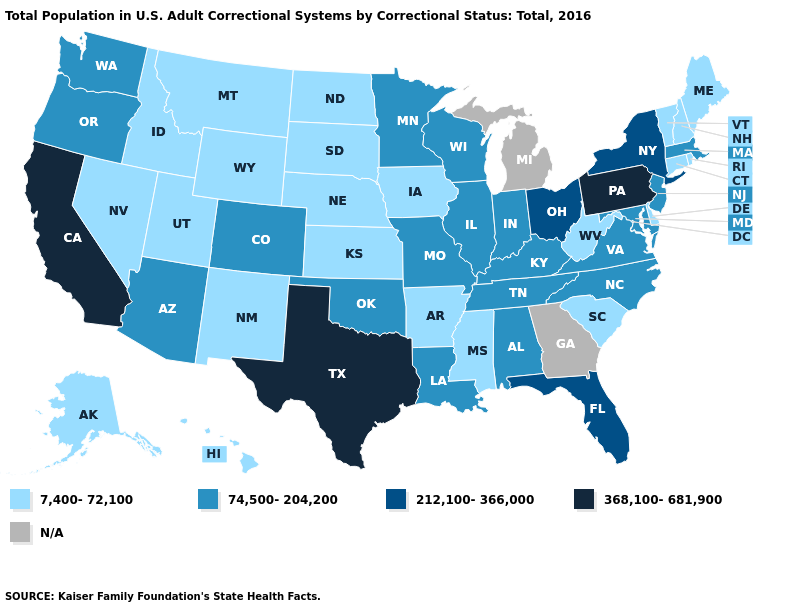What is the value of Nevada?
Write a very short answer. 7,400-72,100. Name the states that have a value in the range N/A?
Keep it brief. Georgia, Michigan. What is the value of Iowa?
Concise answer only. 7,400-72,100. Does the map have missing data?
Keep it brief. Yes. Among the states that border North Dakota , which have the lowest value?
Be succinct. Montana, South Dakota. Name the states that have a value in the range 7,400-72,100?
Answer briefly. Alaska, Arkansas, Connecticut, Delaware, Hawaii, Idaho, Iowa, Kansas, Maine, Mississippi, Montana, Nebraska, Nevada, New Hampshire, New Mexico, North Dakota, Rhode Island, South Carolina, South Dakota, Utah, Vermont, West Virginia, Wyoming. Does Louisiana have the lowest value in the South?
Be succinct. No. Name the states that have a value in the range 74,500-204,200?
Write a very short answer. Alabama, Arizona, Colorado, Illinois, Indiana, Kentucky, Louisiana, Maryland, Massachusetts, Minnesota, Missouri, New Jersey, North Carolina, Oklahoma, Oregon, Tennessee, Virginia, Washington, Wisconsin. Does Nebraska have the lowest value in the USA?
Concise answer only. Yes. What is the value of Alabama?
Concise answer only. 74,500-204,200. Name the states that have a value in the range 7,400-72,100?
Quick response, please. Alaska, Arkansas, Connecticut, Delaware, Hawaii, Idaho, Iowa, Kansas, Maine, Mississippi, Montana, Nebraska, Nevada, New Hampshire, New Mexico, North Dakota, Rhode Island, South Carolina, South Dakota, Utah, Vermont, West Virginia, Wyoming. What is the highest value in states that border Nevada?
Write a very short answer. 368,100-681,900. 